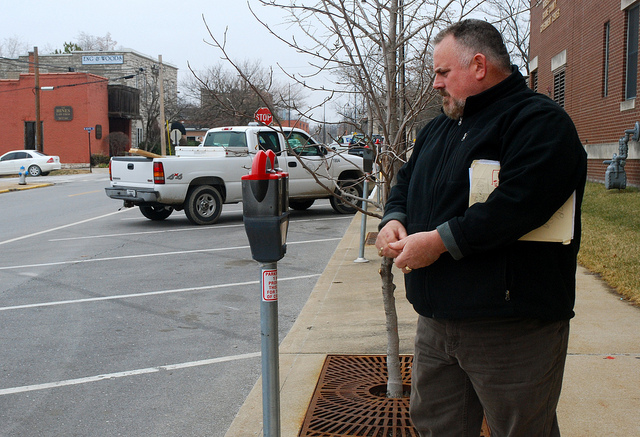Please transcribe the text in this image. STOP 